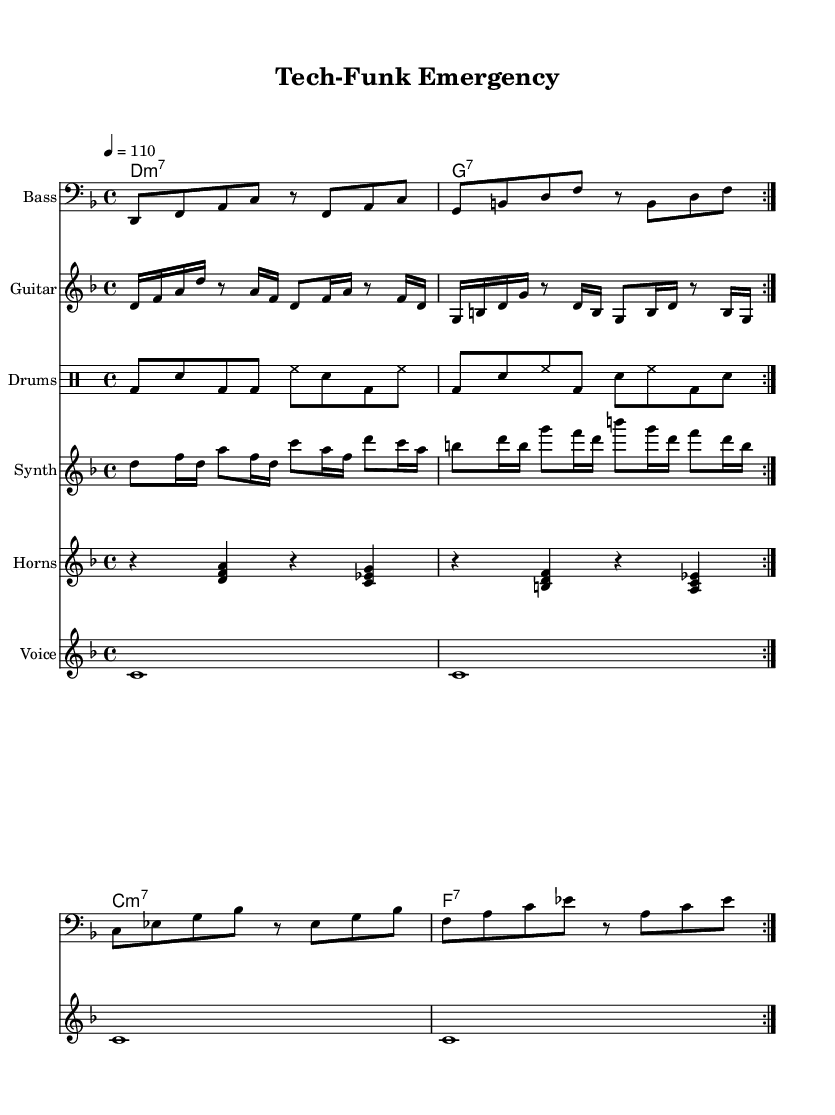What is the key signature of this music? The key signature is indicated by the key signature marking at the beginning of the staff. In this case, it shows one flat, which corresponds to the key of D minor.
Answer: D minor What is the time signature of the piece? The time signature is shown at the beginning of the score as a fraction, which is 4 over 4, indicating four beats in a measure.
Answer: 4/4 What is the tempo marking for the piece? The tempo marking is found above the clef and indicates the speed of the music. It states "4 = 110", meaning there are 110 beats per minute.
Answer: 110 How many volta (repeats) are indicated in the bass line? The bass line includes a "repeat volta" marking, which signifies that the section should be played twice, as indicated in the musical notation.
Answer: 2 What type of instruments are included in this score? The score lists several staves with instrument names, such as Bass, Guitar, Drums, Synth, and Horns, providing a clear list of the instruments used in the piece.
Answer: Bass, Guitar, Drums, Synth, Horns What is the significance of the lyrics about crisis management in a funk piece? The lyrics, which discuss preparedness and technological solutions in the face of a crisis, emphasize the theme of innovation in emergency management, relevant to the funky rhythm and style of the music.
Answer: Technological innovation What is the structure of the melody in the horn section? The horn section has a series of sustained chords and rests, which creates a rich harmonic texture characteristic of funk music, often supporting the rhythmic and melodic content of the ensemble.
Answer: Harmonically driven 